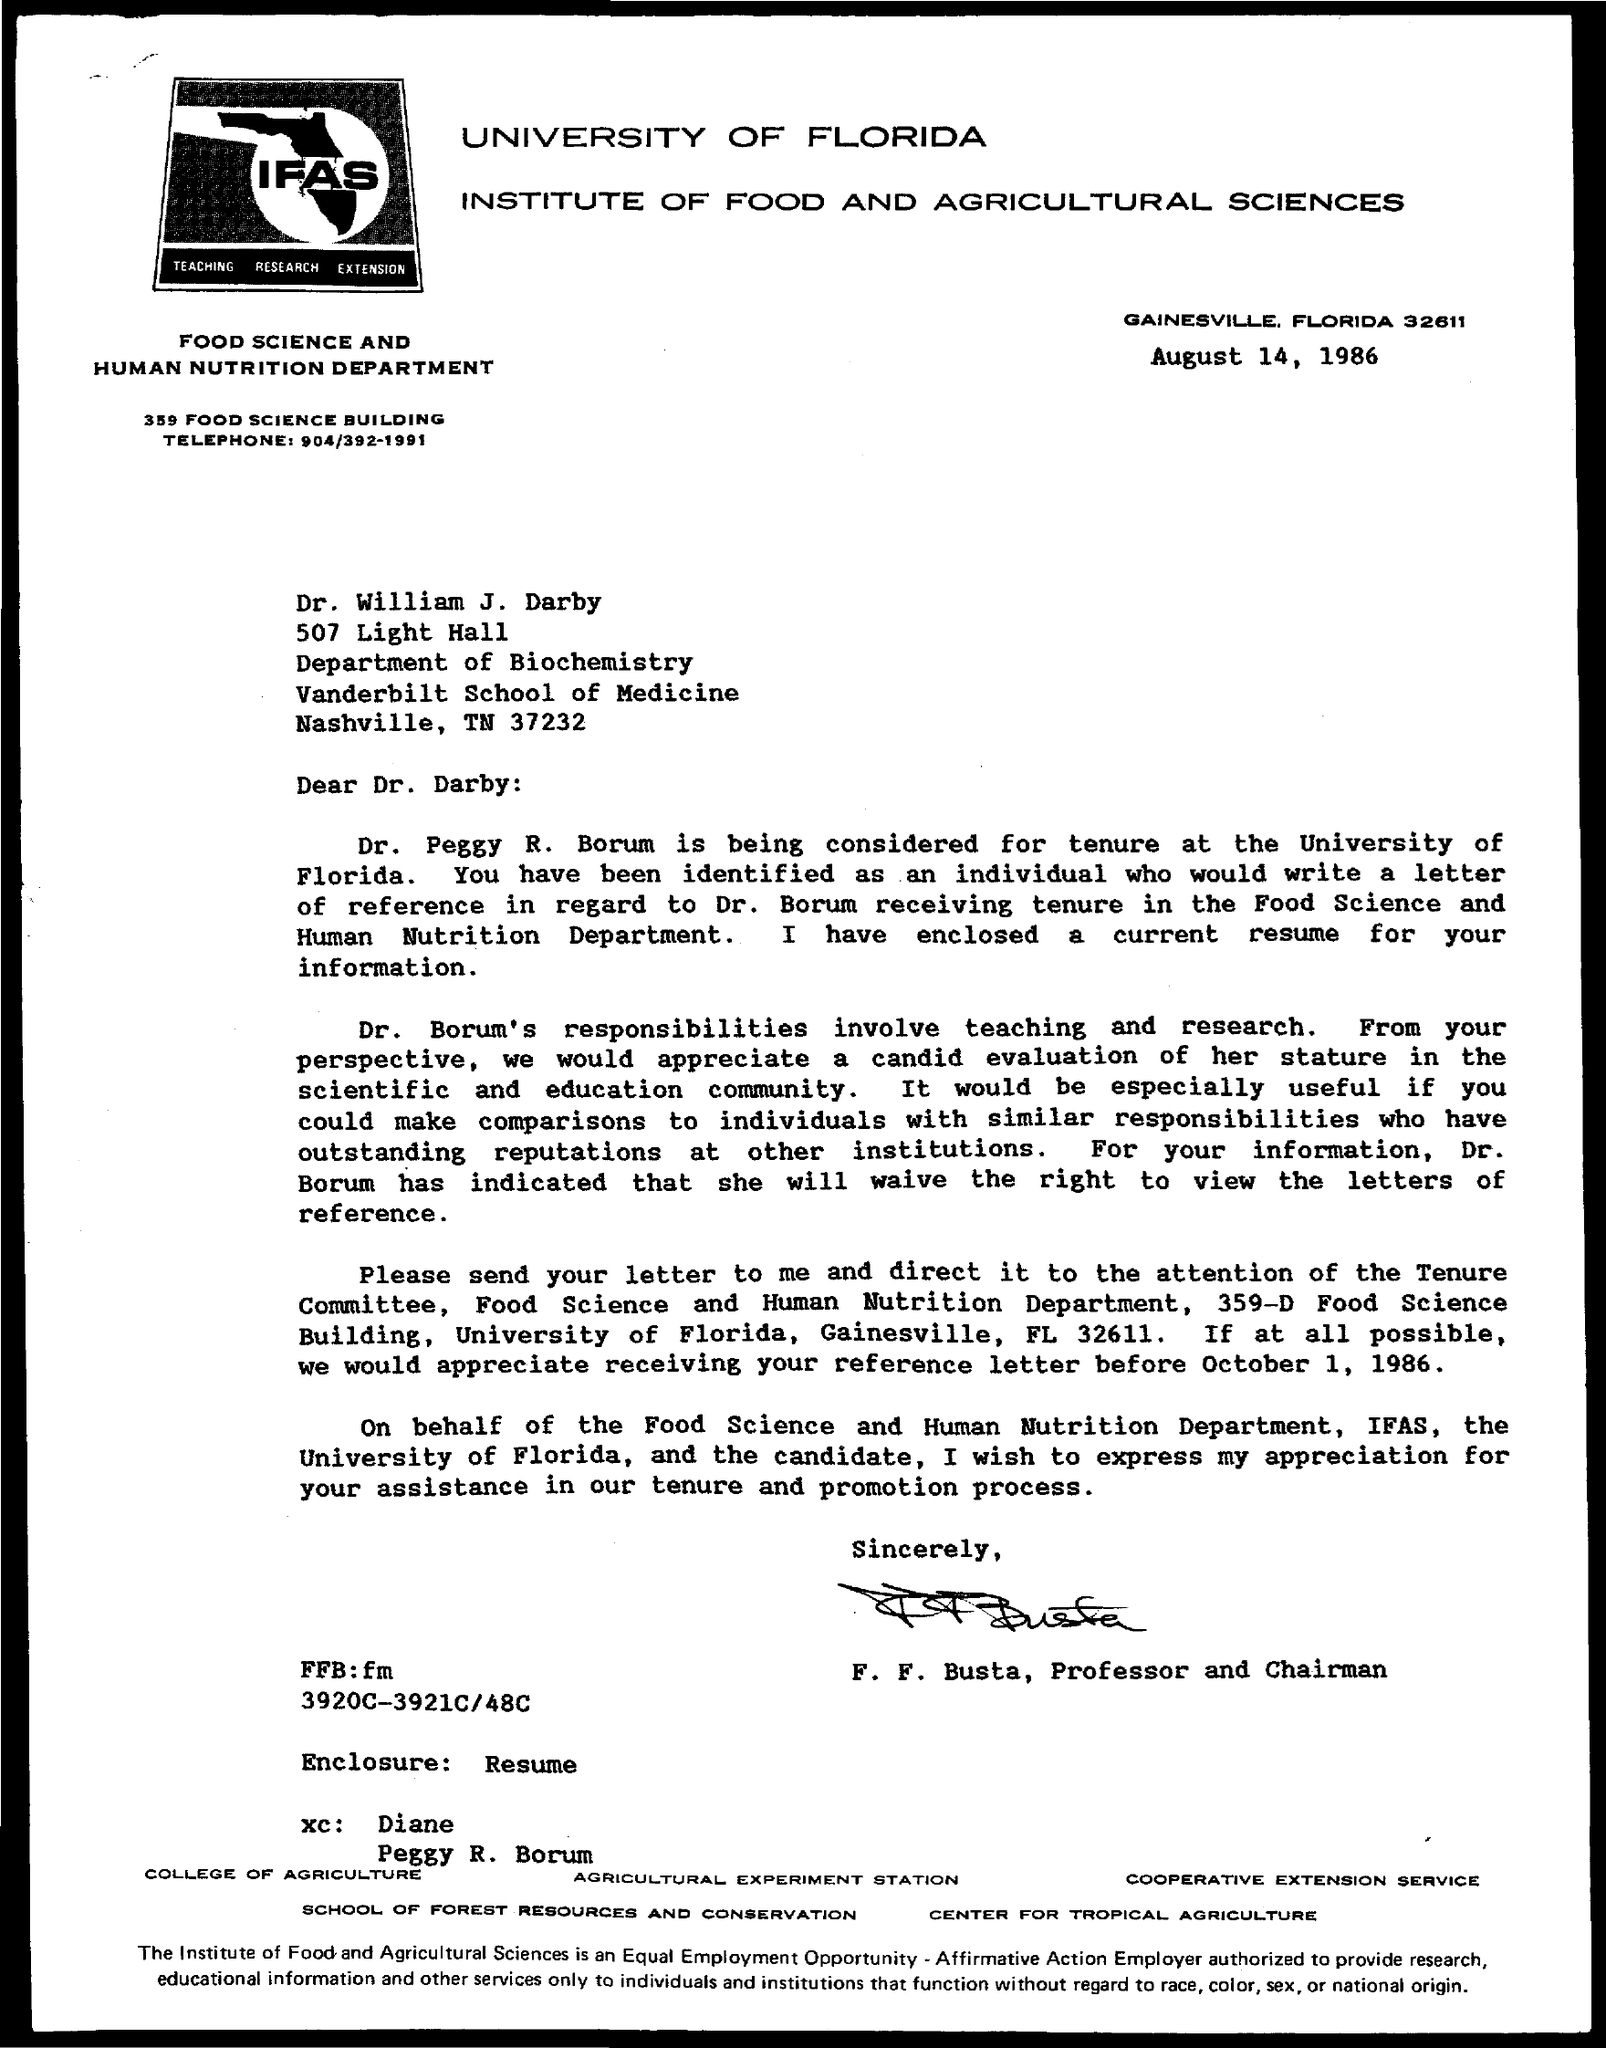What is the date on the document?
Offer a very short reply. August 14, 1986. To Whom is this letter addressed to?
Your answer should be very brief. Dr. William J. Darby. 